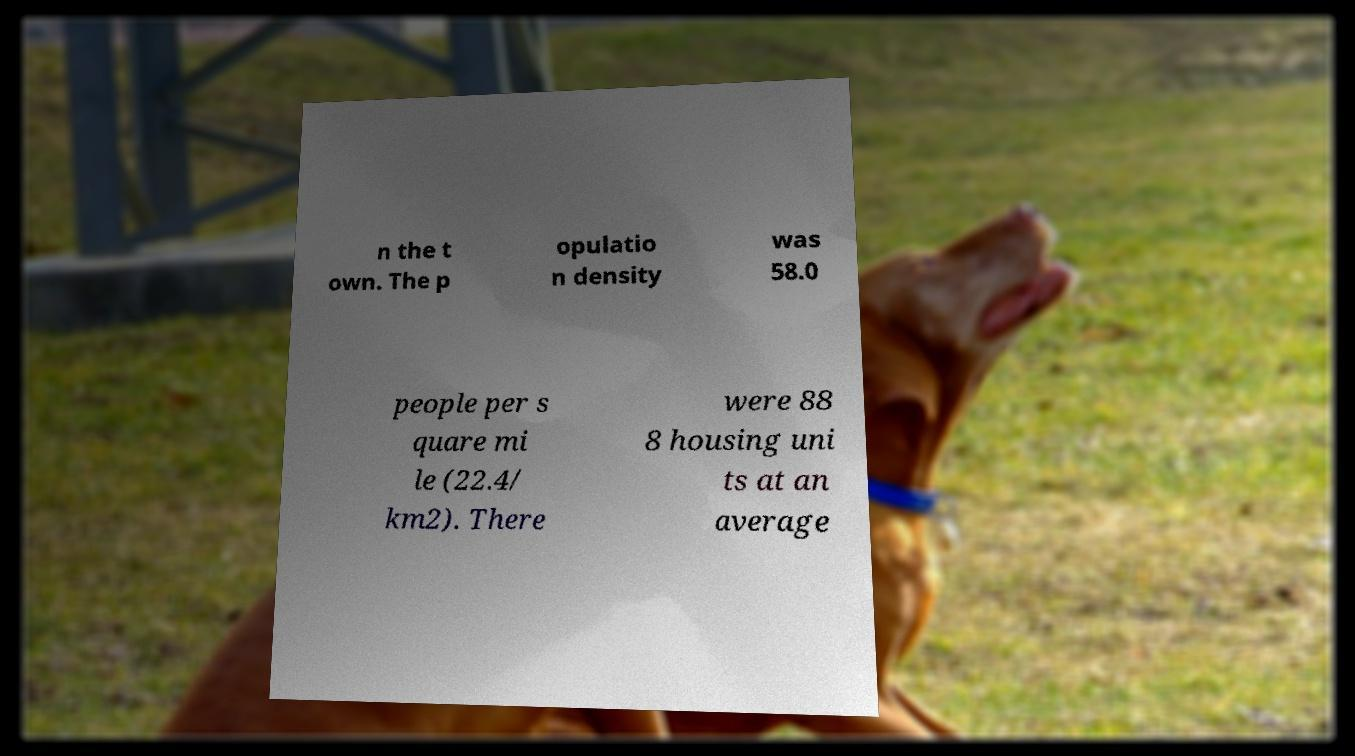For documentation purposes, I need the text within this image transcribed. Could you provide that? n the t own. The p opulatio n density was 58.0 people per s quare mi le (22.4/ km2). There were 88 8 housing uni ts at an average 